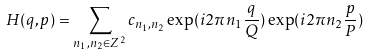Convert formula to latex. <formula><loc_0><loc_0><loc_500><loc_500>H ( q , p ) = \sum _ { n _ { 1 } , n _ { 2 } \in Z ^ { 2 } } c _ { n _ { 1 } , n _ { 2 } } \exp ( i 2 \pi n _ { 1 } \frac { q } { Q } ) \exp ( i 2 \pi n _ { 2 } \frac { p } { P } )</formula> 